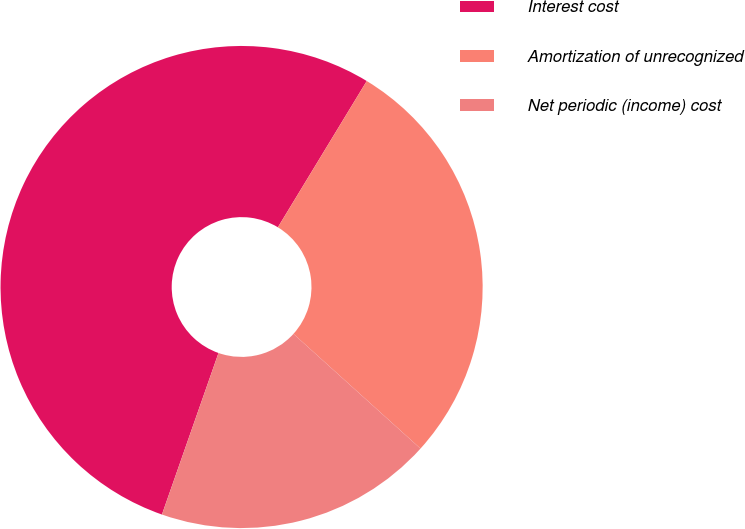Convert chart to OTSL. <chart><loc_0><loc_0><loc_500><loc_500><pie_chart><fcel>Interest cost<fcel>Amortization of unrecognized<fcel>Net periodic (income) cost<nl><fcel>53.33%<fcel>28.0%<fcel>18.67%<nl></chart> 